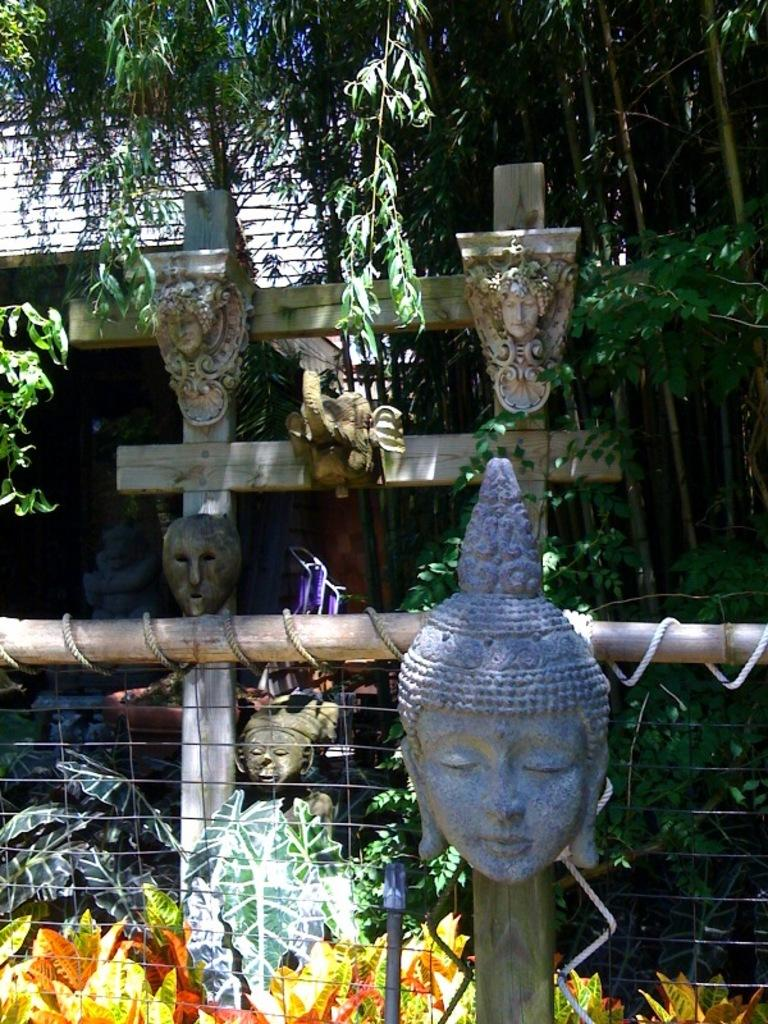What type of art is present in the image? There are sculptures in the image. What is located at the bottom of the image? There is a fence at the bottom of the image. What type of vegetation can be seen in the image? Plants are visible in the image. What can be seen in the background of the image? There are trees and a shed in the background of the image. Can you describe the argument between the men in the image? There are no men or argument present in the image. 